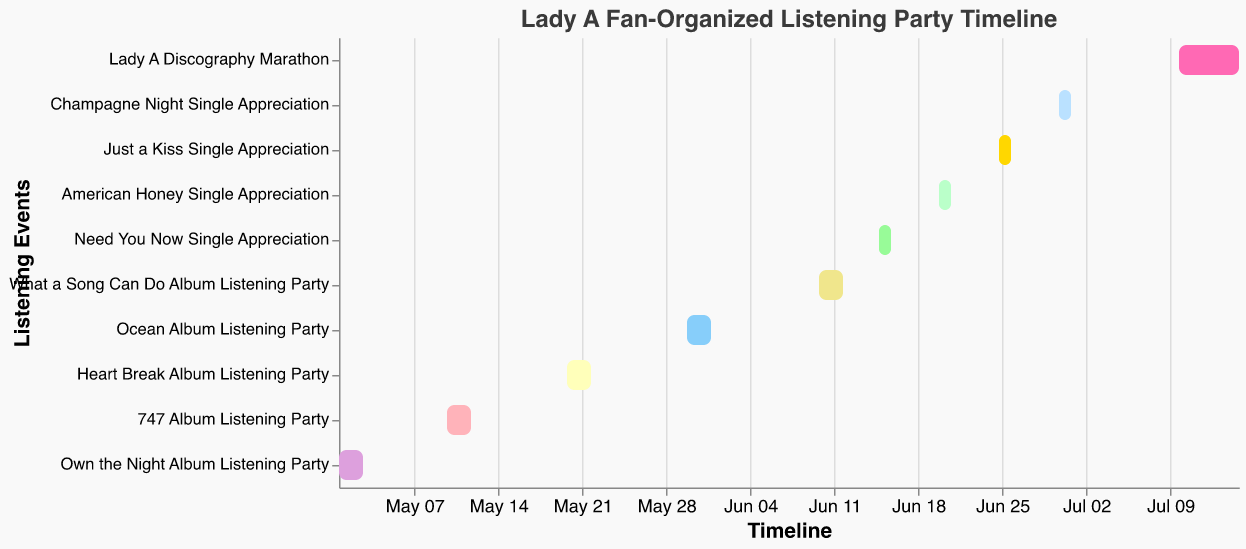What's the title of the Gantt Chart? The title is shown at the top of the chart, and it reads "Lady A Fan-Organized Listening Party Timeline."
Answer: Lady A Fan-Organized Listening Party Timeline What is the start date of the "Heart Break" album listening party? Look for the "Heart Break Album Listening Party" bar and check its leftmost end; the start date is indicated as May 20, 2023.
Answer: May 20, 2023 Which listening event lasts the longest? Compare the durations of each bar by measuring the span between the start and end dates for each event. The "Lady A Discography Marathon" spans six days from July 10 to July 15.
Answer: Lady A Discography Marathon How many listening events happen in June 2023? Identify and count the bars that start or end in June 2023. There are five: "What a Song Can Do Album Listening Party," "Need You Now Single Appreciation," "American Honey Single Appreciation," "Just a Kiss Single Appreciation," and "Champagne Night Single Appreciation."
Answer: 5 Which album listening party comes right after "Ocean"? Look at the timeline and find the next bar after the "Ocean Album Listening Party," which is "What a Song Can Do Album Listening Party."
Answer: What a Song Can Do Album Listening Party What is the duration of the "Champagne Night" single appreciation event? The duration can be calculated by counting the days between the start and end dates. For "Champagne Night Single Appreciation," it runs from June 30 to July 1, which is 2 days.
Answer: 2 days What is the earliest event in the timeline? The earliest event is the leftmost bar on the Gantt chart, which is "Own the Night Album Listening Party," starting on May 1, 2023.
Answer: Own the Night Album Listening Party Compare the duration of "Just a Kiss" and "American Honey" listening events. Which is shorter? Both events have the same duration. The "Just a Kiss Single Appreciation" lasts from June 25 to June 26, and the "American Honey Single Appreciation" lasts from June 20 to June 21. Both are 2 days long.
Answer: Both are equal What is the total number of different listening parties (both album and single)? Count all the distinct bars on the Gantt chart. There are nine distinct listening parties.
Answer: 10 What’s the gap between the end of the "747" album listening party and the start of the "Heart Break" album listening party? "747 Album Listening Party" ends on May 12, and "Heart Break Album Listening Party" begins on May 20. Calculate the gap by counting the days between May 13 and May 19. A total of 8 days gap.
Answer: 8 days 